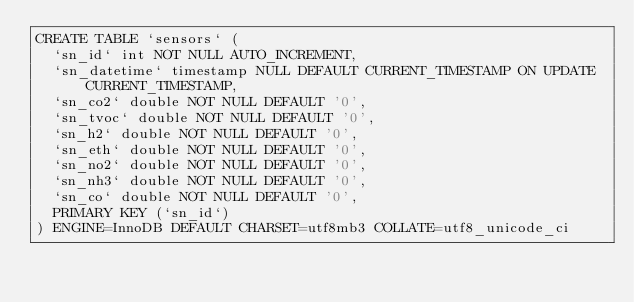<code> <loc_0><loc_0><loc_500><loc_500><_SQL_>CREATE TABLE `sensors` (
  `sn_id` int NOT NULL AUTO_INCREMENT,
  `sn_datetime` timestamp NULL DEFAULT CURRENT_TIMESTAMP ON UPDATE CURRENT_TIMESTAMP,
  `sn_co2` double NOT NULL DEFAULT '0',
  `sn_tvoc` double NOT NULL DEFAULT '0',
  `sn_h2` double NOT NULL DEFAULT '0',
  `sn_eth` double NOT NULL DEFAULT '0',
  `sn_no2` double NOT NULL DEFAULT '0',
  `sn_nh3` double NOT NULL DEFAULT '0',
  `sn_co` double NOT NULL DEFAULT '0',
  PRIMARY KEY (`sn_id`)
) ENGINE=InnoDB DEFAULT CHARSET=utf8mb3 COLLATE=utf8_unicode_ci</code> 